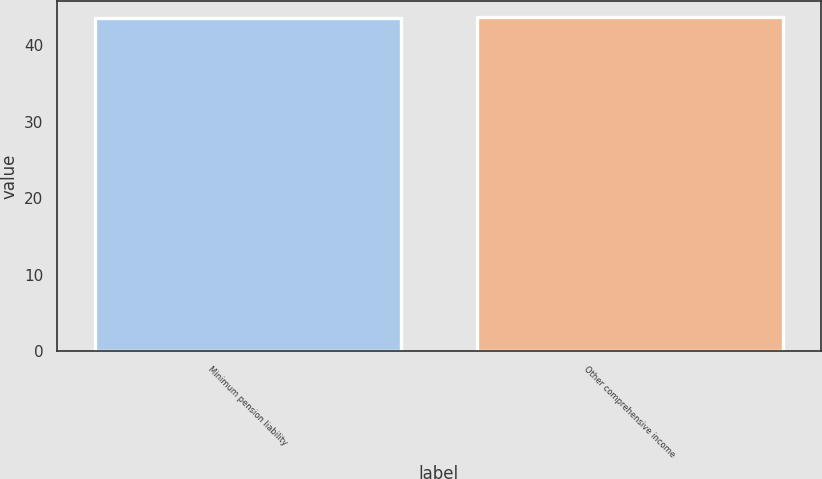<chart> <loc_0><loc_0><loc_500><loc_500><bar_chart><fcel>Minimum pension liability<fcel>Other comprehensive income<nl><fcel>43.5<fcel>43.6<nl></chart> 